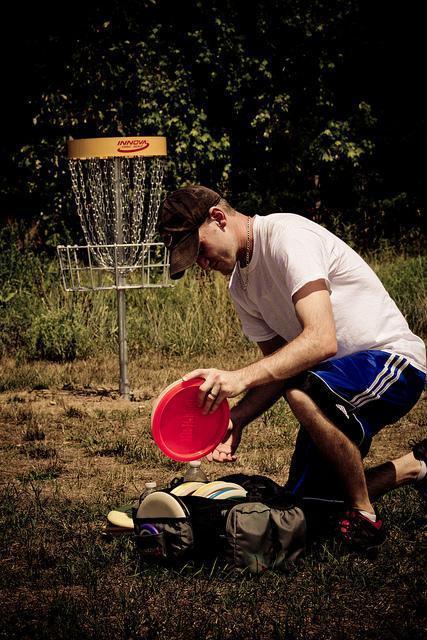How many white vertical stripes are on the man's shorts?
Give a very brief answer. 3. 